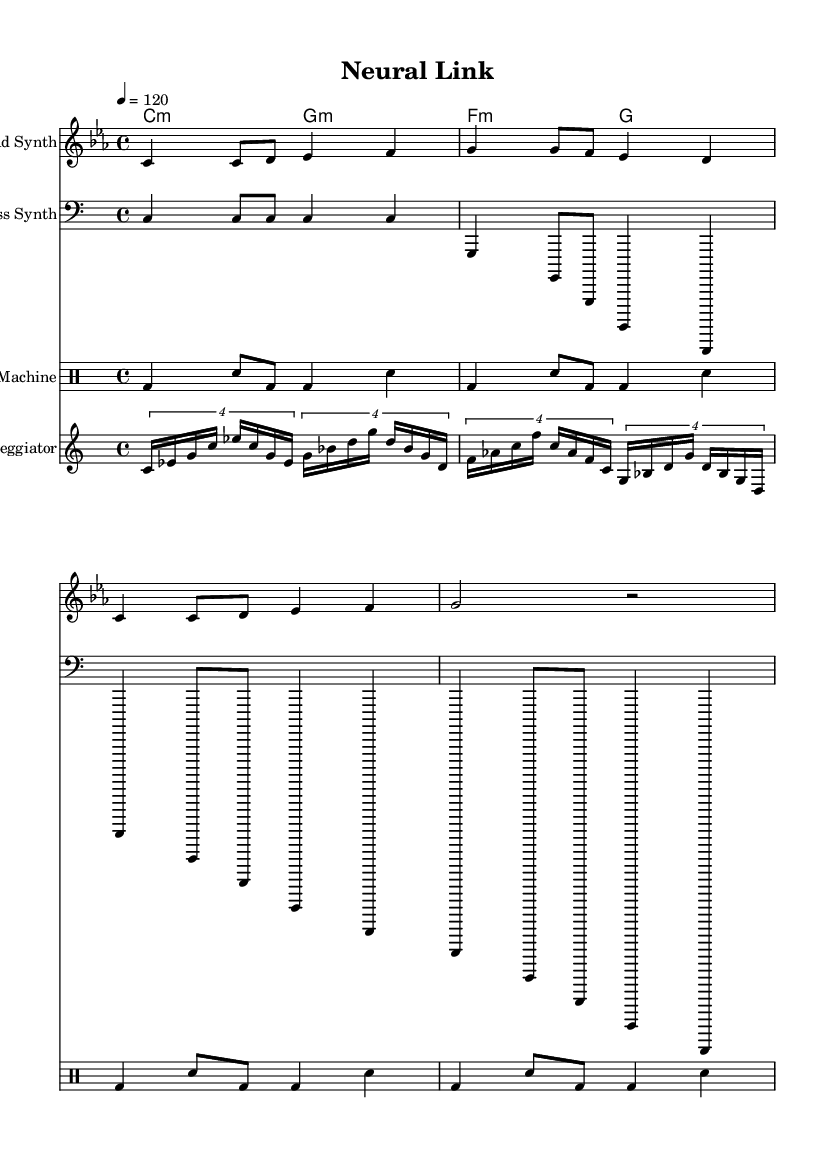What is the key signature of this music? The key signature is C minor, which has three flats (B♭, E♭, A♭). This can be identified in the global settings at the beginning of the music score.
Answer: C minor What is the time signature of this music? The time signature shown in the global section is 4/4, which indicates that there are four beats in each measure. This information is clearly marked right after the key signature.
Answer: 4/4 What is the tempo marking for this piece? The tempo marking at the start of the score indicates a speed of 120 beats per minute. This is defined in the global section as 4 = 120.
Answer: 120 How many measures are in the melody section? Counting the notes and bar lines in the melody part, there are a total of four measures present. This can be verified by looking at the grouping of notes under the melody staff section.
Answer: Four What is the first lyric line of the song? The first lyric line displayed under the melody is “Connected to the mainframe," which is part of the text indicated in the lyric mode section right below the melody notes.
Answer: Connected to the mainframe What kind of synthesizers are specified in the sheet music? The sheet music specifies a "Lead Synth" for the melody, a "Bass Synth" for the bassline, and it also includes an "Arpeggiator". This can be found in the label of each staff in the score section.
Answer: Lead Synth, Bass Synth, Arpeggiator How many different instrument parts are notated in the score? There are a total of five different instrument parts notated in the score, which includes the Lead Synth, Bass Synth, Arpeggiator, and Drum Machine, alongside the Chord Names section.
Answer: Five 